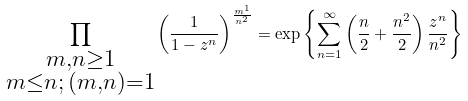Convert formula to latex. <formula><loc_0><loc_0><loc_500><loc_500>\prod _ { \substack { m , n \geq 1 \\ m \leq n ; \, ( m , n ) = 1 } } \left ( \frac { 1 } { 1 - z ^ { n } } \right ) ^ { \frac { m ^ { 1 } } { n ^ { 2 } } } = \exp \left \{ \sum _ { n = 1 } ^ { \infty } \left ( \frac { n } { 2 } + \frac { n ^ { 2 } } { 2 } \right ) \frac { z ^ { n } } { n ^ { 2 } } \right \}</formula> 